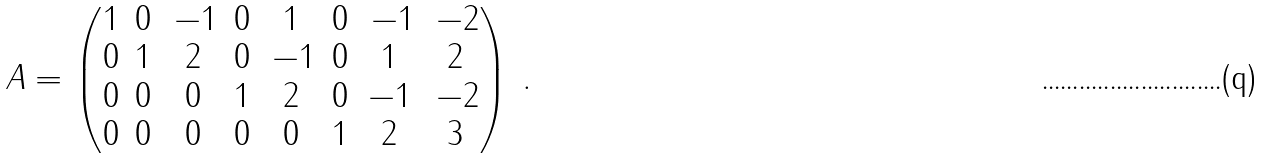<formula> <loc_0><loc_0><loc_500><loc_500>A = \begin{pmatrix} 1 & 0 & \, - 1 & 0 & 1 & 0 & \, - 1 & \, - 2 \\ 0 & 1 & 2 & 0 & \, - 1 & 0 & 1 & 2 \\ 0 & 0 & 0 & 1 & 2 & 0 & - 1 & \, - 2 \\ 0 & 0 & 0 & 0 & 0 & 1 & 2 & 3 \end{pmatrix} \, .</formula> 